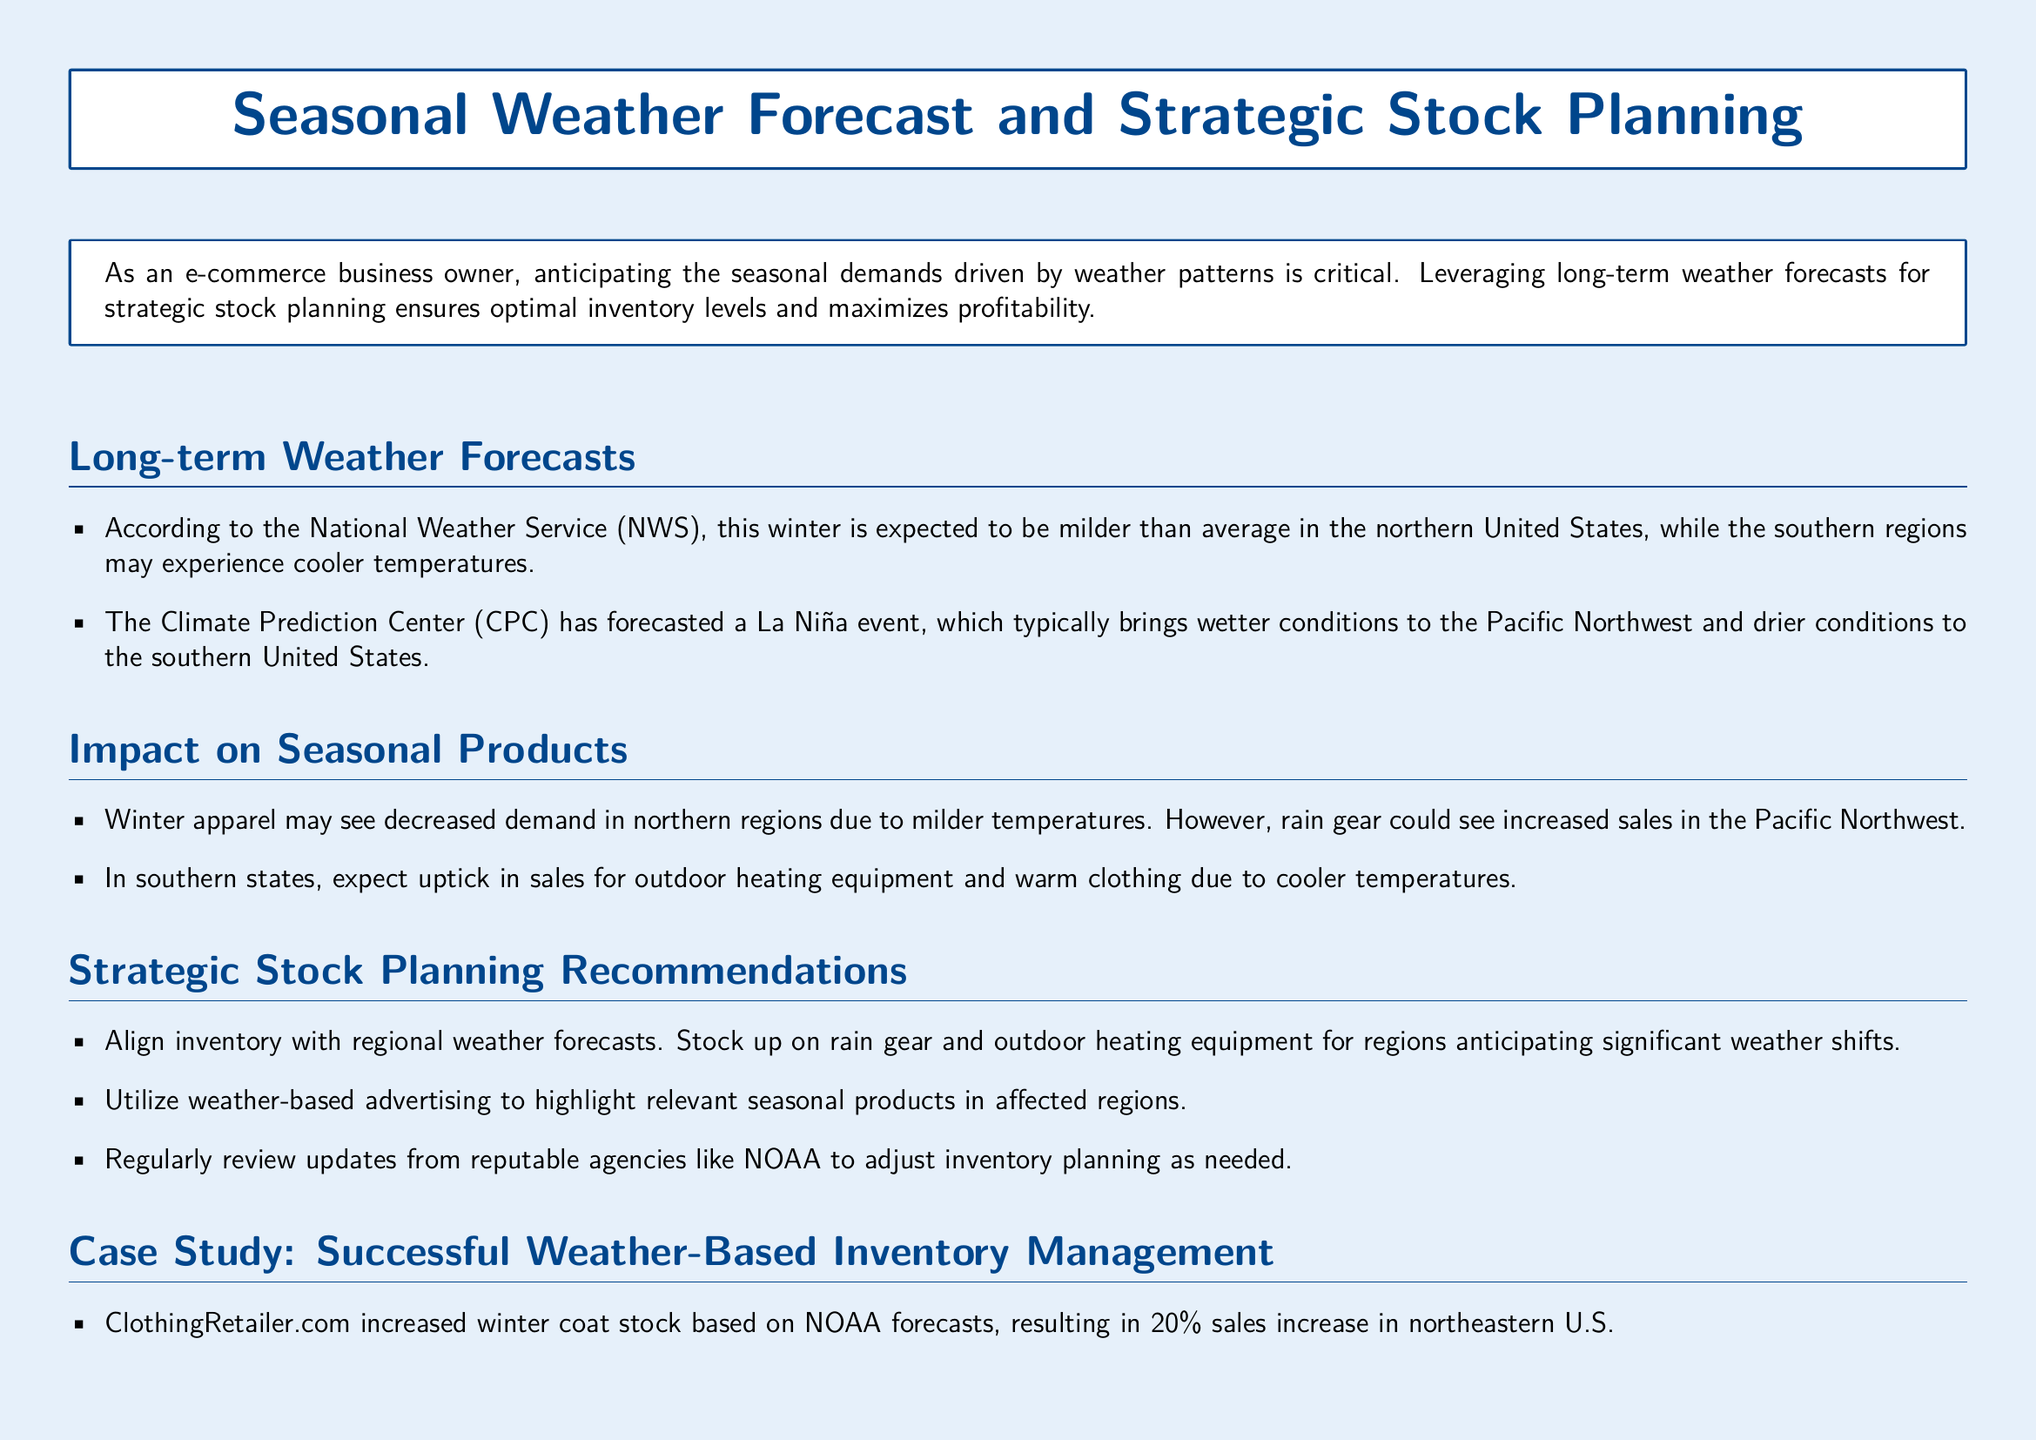What is the expected winter temperature trend in northern United States? The document states that this winter is expected to be milder than average in the northern United States.
Answer: milder What event is forecasted by the Climate Prediction Center? According to the document, the Climate Prediction Center has forecasted a La Niña event.
Answer: La Niña Which product category may see increased demand in the Pacific Northwest? The document mentions that rain gear could see increased sales in the Pacific Northwest due to wetter conditions.
Answer: rain gear What percentage increase in sales did ClothingRetailer.com achieve by adjusting inventory? The document notes that ClothingRetailer.com resulted in a 20% sales increase in the northeastern U.S. by increasing winter coat stock.
Answer: 20% What type of equipment should be stocked in southern states according to the forecast? The document indicates that there is an expected uptick in sales for outdoor heating equipment in southern states due to cooler temperatures.
Answer: outdoor heating equipment How should inventory be aligned according to the recommendations? The document recommends to align inventory with regional weather forecasts.
Answer: regional weather forecasts What agency should be regularly reviewed for updates? The document specifically mentions that updates should be regularly reviewed from reputable agencies like NOAA.
Answer: NOAA What was the sales increase percentage for OutdoorGearHub in the Pacific Northwest? According to the case study in the document, OutdoorGearHub led to a 15% rise in regional sales.
Answer: 15% 